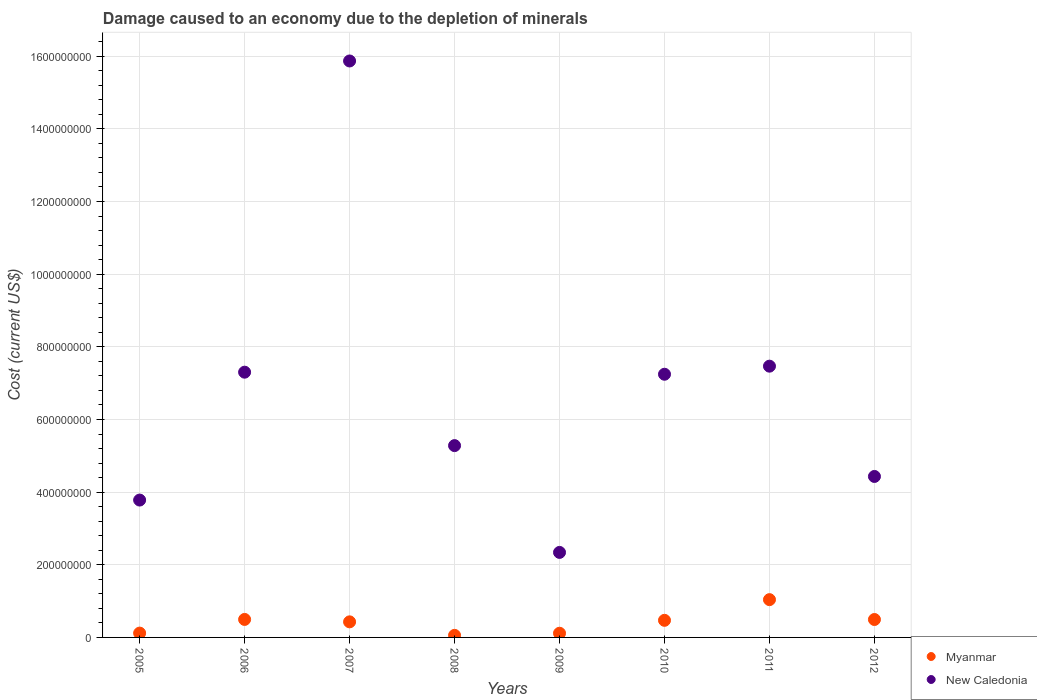How many different coloured dotlines are there?
Keep it short and to the point. 2. Is the number of dotlines equal to the number of legend labels?
Provide a succinct answer. Yes. What is the cost of damage caused due to the depletion of minerals in New Caledonia in 2006?
Give a very brief answer. 7.30e+08. Across all years, what is the maximum cost of damage caused due to the depletion of minerals in New Caledonia?
Your answer should be very brief. 1.59e+09. Across all years, what is the minimum cost of damage caused due to the depletion of minerals in New Caledonia?
Keep it short and to the point. 2.34e+08. What is the total cost of damage caused due to the depletion of minerals in Myanmar in the graph?
Provide a short and direct response. 3.22e+08. What is the difference between the cost of damage caused due to the depletion of minerals in New Caledonia in 2010 and that in 2011?
Offer a terse response. -2.22e+07. What is the difference between the cost of damage caused due to the depletion of minerals in New Caledonia in 2011 and the cost of damage caused due to the depletion of minerals in Myanmar in 2010?
Ensure brevity in your answer.  7.00e+08. What is the average cost of damage caused due to the depletion of minerals in New Caledonia per year?
Your answer should be very brief. 6.71e+08. In the year 2010, what is the difference between the cost of damage caused due to the depletion of minerals in Myanmar and cost of damage caused due to the depletion of minerals in New Caledonia?
Offer a terse response. -6.77e+08. In how many years, is the cost of damage caused due to the depletion of minerals in New Caledonia greater than 360000000 US$?
Keep it short and to the point. 7. What is the ratio of the cost of damage caused due to the depletion of minerals in Myanmar in 2005 to that in 2012?
Offer a terse response. 0.24. Is the cost of damage caused due to the depletion of minerals in New Caledonia in 2009 less than that in 2012?
Offer a very short reply. Yes. Is the difference between the cost of damage caused due to the depletion of minerals in Myanmar in 2007 and 2009 greater than the difference between the cost of damage caused due to the depletion of minerals in New Caledonia in 2007 and 2009?
Offer a very short reply. No. What is the difference between the highest and the second highest cost of damage caused due to the depletion of minerals in New Caledonia?
Your answer should be very brief. 8.40e+08. What is the difference between the highest and the lowest cost of damage caused due to the depletion of minerals in New Caledonia?
Offer a very short reply. 1.35e+09. Is the sum of the cost of damage caused due to the depletion of minerals in New Caledonia in 2005 and 2011 greater than the maximum cost of damage caused due to the depletion of minerals in Myanmar across all years?
Provide a succinct answer. Yes. Does the cost of damage caused due to the depletion of minerals in New Caledonia monotonically increase over the years?
Your answer should be compact. No. Is the cost of damage caused due to the depletion of minerals in Myanmar strictly greater than the cost of damage caused due to the depletion of minerals in New Caledonia over the years?
Offer a terse response. No. Does the graph contain grids?
Keep it short and to the point. Yes. Where does the legend appear in the graph?
Provide a short and direct response. Bottom right. How many legend labels are there?
Give a very brief answer. 2. How are the legend labels stacked?
Offer a very short reply. Vertical. What is the title of the graph?
Provide a succinct answer. Damage caused to an economy due to the depletion of minerals. What is the label or title of the X-axis?
Give a very brief answer. Years. What is the label or title of the Y-axis?
Offer a terse response. Cost (current US$). What is the Cost (current US$) of Myanmar in 2005?
Your answer should be compact. 1.19e+07. What is the Cost (current US$) in New Caledonia in 2005?
Give a very brief answer. 3.78e+08. What is the Cost (current US$) in Myanmar in 2006?
Offer a very short reply. 4.95e+07. What is the Cost (current US$) in New Caledonia in 2006?
Offer a very short reply. 7.30e+08. What is the Cost (current US$) of Myanmar in 2007?
Provide a succinct answer. 4.29e+07. What is the Cost (current US$) of New Caledonia in 2007?
Offer a very short reply. 1.59e+09. What is the Cost (current US$) of Myanmar in 2008?
Ensure brevity in your answer.  5.68e+06. What is the Cost (current US$) in New Caledonia in 2008?
Your answer should be compact. 5.28e+08. What is the Cost (current US$) in Myanmar in 2009?
Keep it short and to the point. 1.15e+07. What is the Cost (current US$) in New Caledonia in 2009?
Provide a short and direct response. 2.34e+08. What is the Cost (current US$) in Myanmar in 2010?
Provide a succinct answer. 4.71e+07. What is the Cost (current US$) in New Caledonia in 2010?
Your response must be concise. 7.25e+08. What is the Cost (current US$) of Myanmar in 2011?
Keep it short and to the point. 1.04e+08. What is the Cost (current US$) of New Caledonia in 2011?
Offer a terse response. 7.47e+08. What is the Cost (current US$) in Myanmar in 2012?
Provide a short and direct response. 4.93e+07. What is the Cost (current US$) in New Caledonia in 2012?
Your response must be concise. 4.43e+08. Across all years, what is the maximum Cost (current US$) in Myanmar?
Ensure brevity in your answer.  1.04e+08. Across all years, what is the maximum Cost (current US$) of New Caledonia?
Your answer should be very brief. 1.59e+09. Across all years, what is the minimum Cost (current US$) of Myanmar?
Offer a very short reply. 5.68e+06. Across all years, what is the minimum Cost (current US$) of New Caledonia?
Give a very brief answer. 2.34e+08. What is the total Cost (current US$) in Myanmar in the graph?
Offer a very short reply. 3.22e+08. What is the total Cost (current US$) in New Caledonia in the graph?
Provide a short and direct response. 5.37e+09. What is the difference between the Cost (current US$) of Myanmar in 2005 and that in 2006?
Provide a succinct answer. -3.76e+07. What is the difference between the Cost (current US$) of New Caledonia in 2005 and that in 2006?
Give a very brief answer. -3.52e+08. What is the difference between the Cost (current US$) in Myanmar in 2005 and that in 2007?
Provide a short and direct response. -3.10e+07. What is the difference between the Cost (current US$) of New Caledonia in 2005 and that in 2007?
Your response must be concise. -1.21e+09. What is the difference between the Cost (current US$) in Myanmar in 2005 and that in 2008?
Ensure brevity in your answer.  6.21e+06. What is the difference between the Cost (current US$) of New Caledonia in 2005 and that in 2008?
Your answer should be compact. -1.50e+08. What is the difference between the Cost (current US$) in Myanmar in 2005 and that in 2009?
Make the answer very short. 3.67e+05. What is the difference between the Cost (current US$) of New Caledonia in 2005 and that in 2009?
Offer a very short reply. 1.44e+08. What is the difference between the Cost (current US$) of Myanmar in 2005 and that in 2010?
Give a very brief answer. -3.52e+07. What is the difference between the Cost (current US$) of New Caledonia in 2005 and that in 2010?
Offer a terse response. -3.46e+08. What is the difference between the Cost (current US$) in Myanmar in 2005 and that in 2011?
Provide a short and direct response. -9.21e+07. What is the difference between the Cost (current US$) of New Caledonia in 2005 and that in 2011?
Your response must be concise. -3.69e+08. What is the difference between the Cost (current US$) in Myanmar in 2005 and that in 2012?
Keep it short and to the point. -3.74e+07. What is the difference between the Cost (current US$) of New Caledonia in 2005 and that in 2012?
Your response must be concise. -6.50e+07. What is the difference between the Cost (current US$) of Myanmar in 2006 and that in 2007?
Keep it short and to the point. 6.64e+06. What is the difference between the Cost (current US$) in New Caledonia in 2006 and that in 2007?
Make the answer very short. -8.57e+08. What is the difference between the Cost (current US$) of Myanmar in 2006 and that in 2008?
Provide a succinct answer. 4.39e+07. What is the difference between the Cost (current US$) of New Caledonia in 2006 and that in 2008?
Offer a very short reply. 2.02e+08. What is the difference between the Cost (current US$) in Myanmar in 2006 and that in 2009?
Make the answer very short. 3.80e+07. What is the difference between the Cost (current US$) of New Caledonia in 2006 and that in 2009?
Keep it short and to the point. 4.96e+08. What is the difference between the Cost (current US$) of Myanmar in 2006 and that in 2010?
Keep it short and to the point. 2.46e+06. What is the difference between the Cost (current US$) in New Caledonia in 2006 and that in 2010?
Give a very brief answer. 5.69e+06. What is the difference between the Cost (current US$) of Myanmar in 2006 and that in 2011?
Give a very brief answer. -5.45e+07. What is the difference between the Cost (current US$) of New Caledonia in 2006 and that in 2011?
Your answer should be compact. -1.66e+07. What is the difference between the Cost (current US$) of Myanmar in 2006 and that in 2012?
Your answer should be compact. 2.01e+05. What is the difference between the Cost (current US$) of New Caledonia in 2006 and that in 2012?
Make the answer very short. 2.87e+08. What is the difference between the Cost (current US$) in Myanmar in 2007 and that in 2008?
Your answer should be very brief. 3.72e+07. What is the difference between the Cost (current US$) in New Caledonia in 2007 and that in 2008?
Keep it short and to the point. 1.06e+09. What is the difference between the Cost (current US$) of Myanmar in 2007 and that in 2009?
Ensure brevity in your answer.  3.14e+07. What is the difference between the Cost (current US$) in New Caledonia in 2007 and that in 2009?
Ensure brevity in your answer.  1.35e+09. What is the difference between the Cost (current US$) of Myanmar in 2007 and that in 2010?
Ensure brevity in your answer.  -4.18e+06. What is the difference between the Cost (current US$) of New Caledonia in 2007 and that in 2010?
Give a very brief answer. 8.62e+08. What is the difference between the Cost (current US$) in Myanmar in 2007 and that in 2011?
Give a very brief answer. -6.11e+07. What is the difference between the Cost (current US$) in New Caledonia in 2007 and that in 2011?
Keep it short and to the point. 8.40e+08. What is the difference between the Cost (current US$) in Myanmar in 2007 and that in 2012?
Ensure brevity in your answer.  -6.44e+06. What is the difference between the Cost (current US$) in New Caledonia in 2007 and that in 2012?
Your answer should be very brief. 1.14e+09. What is the difference between the Cost (current US$) of Myanmar in 2008 and that in 2009?
Ensure brevity in your answer.  -5.85e+06. What is the difference between the Cost (current US$) in New Caledonia in 2008 and that in 2009?
Provide a short and direct response. 2.94e+08. What is the difference between the Cost (current US$) in Myanmar in 2008 and that in 2010?
Ensure brevity in your answer.  -4.14e+07. What is the difference between the Cost (current US$) in New Caledonia in 2008 and that in 2010?
Your answer should be very brief. -1.96e+08. What is the difference between the Cost (current US$) of Myanmar in 2008 and that in 2011?
Make the answer very short. -9.83e+07. What is the difference between the Cost (current US$) in New Caledonia in 2008 and that in 2011?
Ensure brevity in your answer.  -2.19e+08. What is the difference between the Cost (current US$) in Myanmar in 2008 and that in 2012?
Make the answer very short. -4.36e+07. What is the difference between the Cost (current US$) of New Caledonia in 2008 and that in 2012?
Offer a very short reply. 8.49e+07. What is the difference between the Cost (current US$) in Myanmar in 2009 and that in 2010?
Offer a terse response. -3.55e+07. What is the difference between the Cost (current US$) in New Caledonia in 2009 and that in 2010?
Your response must be concise. -4.90e+08. What is the difference between the Cost (current US$) in Myanmar in 2009 and that in 2011?
Your answer should be compact. -9.25e+07. What is the difference between the Cost (current US$) of New Caledonia in 2009 and that in 2011?
Your answer should be very brief. -5.13e+08. What is the difference between the Cost (current US$) of Myanmar in 2009 and that in 2012?
Provide a succinct answer. -3.78e+07. What is the difference between the Cost (current US$) of New Caledonia in 2009 and that in 2012?
Provide a succinct answer. -2.09e+08. What is the difference between the Cost (current US$) in Myanmar in 2010 and that in 2011?
Keep it short and to the point. -5.69e+07. What is the difference between the Cost (current US$) of New Caledonia in 2010 and that in 2011?
Keep it short and to the point. -2.22e+07. What is the difference between the Cost (current US$) of Myanmar in 2010 and that in 2012?
Your response must be concise. -2.26e+06. What is the difference between the Cost (current US$) of New Caledonia in 2010 and that in 2012?
Make the answer very short. 2.81e+08. What is the difference between the Cost (current US$) in Myanmar in 2011 and that in 2012?
Ensure brevity in your answer.  5.47e+07. What is the difference between the Cost (current US$) of New Caledonia in 2011 and that in 2012?
Ensure brevity in your answer.  3.04e+08. What is the difference between the Cost (current US$) of Myanmar in 2005 and the Cost (current US$) of New Caledonia in 2006?
Your answer should be very brief. -7.18e+08. What is the difference between the Cost (current US$) of Myanmar in 2005 and the Cost (current US$) of New Caledonia in 2007?
Give a very brief answer. -1.58e+09. What is the difference between the Cost (current US$) in Myanmar in 2005 and the Cost (current US$) in New Caledonia in 2008?
Provide a succinct answer. -5.16e+08. What is the difference between the Cost (current US$) in Myanmar in 2005 and the Cost (current US$) in New Caledonia in 2009?
Your answer should be very brief. -2.22e+08. What is the difference between the Cost (current US$) of Myanmar in 2005 and the Cost (current US$) of New Caledonia in 2010?
Provide a succinct answer. -7.13e+08. What is the difference between the Cost (current US$) in Myanmar in 2005 and the Cost (current US$) in New Caledonia in 2011?
Make the answer very short. -7.35e+08. What is the difference between the Cost (current US$) of Myanmar in 2005 and the Cost (current US$) of New Caledonia in 2012?
Make the answer very short. -4.31e+08. What is the difference between the Cost (current US$) in Myanmar in 2006 and the Cost (current US$) in New Caledonia in 2007?
Make the answer very short. -1.54e+09. What is the difference between the Cost (current US$) of Myanmar in 2006 and the Cost (current US$) of New Caledonia in 2008?
Keep it short and to the point. -4.79e+08. What is the difference between the Cost (current US$) in Myanmar in 2006 and the Cost (current US$) in New Caledonia in 2009?
Your answer should be compact. -1.85e+08. What is the difference between the Cost (current US$) of Myanmar in 2006 and the Cost (current US$) of New Caledonia in 2010?
Provide a short and direct response. -6.75e+08. What is the difference between the Cost (current US$) of Myanmar in 2006 and the Cost (current US$) of New Caledonia in 2011?
Ensure brevity in your answer.  -6.97e+08. What is the difference between the Cost (current US$) in Myanmar in 2006 and the Cost (current US$) in New Caledonia in 2012?
Keep it short and to the point. -3.94e+08. What is the difference between the Cost (current US$) of Myanmar in 2007 and the Cost (current US$) of New Caledonia in 2008?
Your answer should be very brief. -4.85e+08. What is the difference between the Cost (current US$) of Myanmar in 2007 and the Cost (current US$) of New Caledonia in 2009?
Keep it short and to the point. -1.91e+08. What is the difference between the Cost (current US$) in Myanmar in 2007 and the Cost (current US$) in New Caledonia in 2010?
Your answer should be compact. -6.82e+08. What is the difference between the Cost (current US$) in Myanmar in 2007 and the Cost (current US$) in New Caledonia in 2011?
Provide a succinct answer. -7.04e+08. What is the difference between the Cost (current US$) in Myanmar in 2007 and the Cost (current US$) in New Caledonia in 2012?
Provide a short and direct response. -4.00e+08. What is the difference between the Cost (current US$) in Myanmar in 2008 and the Cost (current US$) in New Caledonia in 2009?
Your answer should be compact. -2.28e+08. What is the difference between the Cost (current US$) of Myanmar in 2008 and the Cost (current US$) of New Caledonia in 2010?
Offer a very short reply. -7.19e+08. What is the difference between the Cost (current US$) of Myanmar in 2008 and the Cost (current US$) of New Caledonia in 2011?
Your response must be concise. -7.41e+08. What is the difference between the Cost (current US$) of Myanmar in 2008 and the Cost (current US$) of New Caledonia in 2012?
Provide a succinct answer. -4.37e+08. What is the difference between the Cost (current US$) of Myanmar in 2009 and the Cost (current US$) of New Caledonia in 2010?
Offer a very short reply. -7.13e+08. What is the difference between the Cost (current US$) in Myanmar in 2009 and the Cost (current US$) in New Caledonia in 2011?
Provide a succinct answer. -7.35e+08. What is the difference between the Cost (current US$) of Myanmar in 2009 and the Cost (current US$) of New Caledonia in 2012?
Your response must be concise. -4.32e+08. What is the difference between the Cost (current US$) in Myanmar in 2010 and the Cost (current US$) in New Caledonia in 2011?
Your answer should be compact. -7.00e+08. What is the difference between the Cost (current US$) of Myanmar in 2010 and the Cost (current US$) of New Caledonia in 2012?
Ensure brevity in your answer.  -3.96e+08. What is the difference between the Cost (current US$) in Myanmar in 2011 and the Cost (current US$) in New Caledonia in 2012?
Provide a short and direct response. -3.39e+08. What is the average Cost (current US$) of Myanmar per year?
Keep it short and to the point. 4.02e+07. What is the average Cost (current US$) in New Caledonia per year?
Your response must be concise. 6.71e+08. In the year 2005, what is the difference between the Cost (current US$) of Myanmar and Cost (current US$) of New Caledonia?
Your answer should be compact. -3.66e+08. In the year 2006, what is the difference between the Cost (current US$) of Myanmar and Cost (current US$) of New Caledonia?
Your answer should be very brief. -6.81e+08. In the year 2007, what is the difference between the Cost (current US$) in Myanmar and Cost (current US$) in New Caledonia?
Give a very brief answer. -1.54e+09. In the year 2008, what is the difference between the Cost (current US$) of Myanmar and Cost (current US$) of New Caledonia?
Your answer should be very brief. -5.22e+08. In the year 2009, what is the difference between the Cost (current US$) in Myanmar and Cost (current US$) in New Caledonia?
Your response must be concise. -2.23e+08. In the year 2010, what is the difference between the Cost (current US$) of Myanmar and Cost (current US$) of New Caledonia?
Your answer should be compact. -6.77e+08. In the year 2011, what is the difference between the Cost (current US$) of Myanmar and Cost (current US$) of New Caledonia?
Provide a short and direct response. -6.43e+08. In the year 2012, what is the difference between the Cost (current US$) in Myanmar and Cost (current US$) in New Caledonia?
Give a very brief answer. -3.94e+08. What is the ratio of the Cost (current US$) in Myanmar in 2005 to that in 2006?
Your answer should be very brief. 0.24. What is the ratio of the Cost (current US$) in New Caledonia in 2005 to that in 2006?
Offer a very short reply. 0.52. What is the ratio of the Cost (current US$) of Myanmar in 2005 to that in 2007?
Give a very brief answer. 0.28. What is the ratio of the Cost (current US$) of New Caledonia in 2005 to that in 2007?
Give a very brief answer. 0.24. What is the ratio of the Cost (current US$) of Myanmar in 2005 to that in 2008?
Offer a very short reply. 2.09. What is the ratio of the Cost (current US$) in New Caledonia in 2005 to that in 2008?
Ensure brevity in your answer.  0.72. What is the ratio of the Cost (current US$) of Myanmar in 2005 to that in 2009?
Give a very brief answer. 1.03. What is the ratio of the Cost (current US$) of New Caledonia in 2005 to that in 2009?
Offer a very short reply. 1.62. What is the ratio of the Cost (current US$) of Myanmar in 2005 to that in 2010?
Make the answer very short. 0.25. What is the ratio of the Cost (current US$) of New Caledonia in 2005 to that in 2010?
Your answer should be very brief. 0.52. What is the ratio of the Cost (current US$) in Myanmar in 2005 to that in 2011?
Provide a short and direct response. 0.11. What is the ratio of the Cost (current US$) of New Caledonia in 2005 to that in 2011?
Offer a very short reply. 0.51. What is the ratio of the Cost (current US$) in Myanmar in 2005 to that in 2012?
Offer a very short reply. 0.24. What is the ratio of the Cost (current US$) in New Caledonia in 2005 to that in 2012?
Your response must be concise. 0.85. What is the ratio of the Cost (current US$) of Myanmar in 2006 to that in 2007?
Offer a very short reply. 1.15. What is the ratio of the Cost (current US$) of New Caledonia in 2006 to that in 2007?
Make the answer very short. 0.46. What is the ratio of the Cost (current US$) of Myanmar in 2006 to that in 2008?
Keep it short and to the point. 8.72. What is the ratio of the Cost (current US$) of New Caledonia in 2006 to that in 2008?
Your response must be concise. 1.38. What is the ratio of the Cost (current US$) of Myanmar in 2006 to that in 2009?
Ensure brevity in your answer.  4.3. What is the ratio of the Cost (current US$) of New Caledonia in 2006 to that in 2009?
Provide a succinct answer. 3.12. What is the ratio of the Cost (current US$) in Myanmar in 2006 to that in 2010?
Provide a short and direct response. 1.05. What is the ratio of the Cost (current US$) in New Caledonia in 2006 to that in 2010?
Your answer should be compact. 1.01. What is the ratio of the Cost (current US$) of Myanmar in 2006 to that in 2011?
Offer a very short reply. 0.48. What is the ratio of the Cost (current US$) in New Caledonia in 2006 to that in 2011?
Your response must be concise. 0.98. What is the ratio of the Cost (current US$) of New Caledonia in 2006 to that in 2012?
Ensure brevity in your answer.  1.65. What is the ratio of the Cost (current US$) in Myanmar in 2007 to that in 2008?
Keep it short and to the point. 7.55. What is the ratio of the Cost (current US$) of New Caledonia in 2007 to that in 2008?
Offer a terse response. 3.01. What is the ratio of the Cost (current US$) in Myanmar in 2007 to that in 2009?
Offer a terse response. 3.72. What is the ratio of the Cost (current US$) in New Caledonia in 2007 to that in 2009?
Your response must be concise. 6.78. What is the ratio of the Cost (current US$) of Myanmar in 2007 to that in 2010?
Offer a terse response. 0.91. What is the ratio of the Cost (current US$) of New Caledonia in 2007 to that in 2010?
Keep it short and to the point. 2.19. What is the ratio of the Cost (current US$) of Myanmar in 2007 to that in 2011?
Your answer should be compact. 0.41. What is the ratio of the Cost (current US$) of New Caledonia in 2007 to that in 2011?
Your answer should be compact. 2.13. What is the ratio of the Cost (current US$) in Myanmar in 2007 to that in 2012?
Make the answer very short. 0.87. What is the ratio of the Cost (current US$) of New Caledonia in 2007 to that in 2012?
Provide a short and direct response. 3.58. What is the ratio of the Cost (current US$) in Myanmar in 2008 to that in 2009?
Offer a very short reply. 0.49. What is the ratio of the Cost (current US$) of New Caledonia in 2008 to that in 2009?
Make the answer very short. 2.26. What is the ratio of the Cost (current US$) in Myanmar in 2008 to that in 2010?
Your response must be concise. 0.12. What is the ratio of the Cost (current US$) of New Caledonia in 2008 to that in 2010?
Keep it short and to the point. 0.73. What is the ratio of the Cost (current US$) in Myanmar in 2008 to that in 2011?
Provide a short and direct response. 0.05. What is the ratio of the Cost (current US$) of New Caledonia in 2008 to that in 2011?
Provide a short and direct response. 0.71. What is the ratio of the Cost (current US$) in Myanmar in 2008 to that in 2012?
Offer a very short reply. 0.12. What is the ratio of the Cost (current US$) of New Caledonia in 2008 to that in 2012?
Offer a terse response. 1.19. What is the ratio of the Cost (current US$) in Myanmar in 2009 to that in 2010?
Make the answer very short. 0.24. What is the ratio of the Cost (current US$) in New Caledonia in 2009 to that in 2010?
Your answer should be compact. 0.32. What is the ratio of the Cost (current US$) of Myanmar in 2009 to that in 2011?
Your response must be concise. 0.11. What is the ratio of the Cost (current US$) of New Caledonia in 2009 to that in 2011?
Provide a succinct answer. 0.31. What is the ratio of the Cost (current US$) of Myanmar in 2009 to that in 2012?
Give a very brief answer. 0.23. What is the ratio of the Cost (current US$) in New Caledonia in 2009 to that in 2012?
Your answer should be very brief. 0.53. What is the ratio of the Cost (current US$) in Myanmar in 2010 to that in 2011?
Your answer should be very brief. 0.45. What is the ratio of the Cost (current US$) in New Caledonia in 2010 to that in 2011?
Provide a succinct answer. 0.97. What is the ratio of the Cost (current US$) in Myanmar in 2010 to that in 2012?
Your response must be concise. 0.95. What is the ratio of the Cost (current US$) of New Caledonia in 2010 to that in 2012?
Offer a very short reply. 1.64. What is the ratio of the Cost (current US$) in Myanmar in 2011 to that in 2012?
Provide a succinct answer. 2.11. What is the ratio of the Cost (current US$) in New Caledonia in 2011 to that in 2012?
Ensure brevity in your answer.  1.69. What is the difference between the highest and the second highest Cost (current US$) in Myanmar?
Provide a succinct answer. 5.45e+07. What is the difference between the highest and the second highest Cost (current US$) of New Caledonia?
Offer a very short reply. 8.40e+08. What is the difference between the highest and the lowest Cost (current US$) in Myanmar?
Provide a short and direct response. 9.83e+07. What is the difference between the highest and the lowest Cost (current US$) in New Caledonia?
Offer a very short reply. 1.35e+09. 